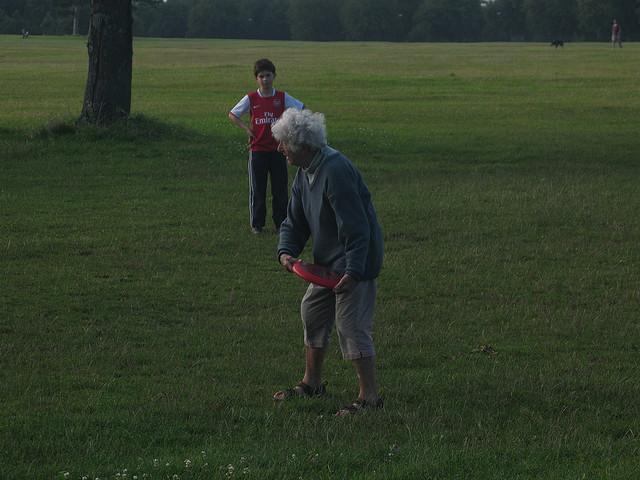Is it a hot day?
Be succinct. No. What color is the woman's sweater?
Keep it brief. Gray. What color is the man's jacket?
Give a very brief answer. Gray. Is this a cloudy day?
Answer briefly. Yes. What game are these people playing?
Concise answer only. Frisbee. Are both men wearing shorts?
Give a very brief answer. No. What color is the coat?
Answer briefly. Gray. Are they indoors or outside?
Give a very brief answer. Outside. What color is the frisbee?
Keep it brief. Red. What is the exact height of the grass?
Short answer required. 2 inches. Is the boy wearing a soccer jersey?
Give a very brief answer. Yes. How many people in this photo?
Be succinct. 2. What is the man wearing?
Concise answer only. Sweater. Is it sunny?
Short answer required. No. Does the grass need watering?
Be succinct. No. What animal is that?
Short answer required. Human. What are the white arms in the background producing?
Concise answer only. Nothing. Is there a fence around the property?
Short answer required. No. Is the guy throwing something?
Keep it brief. Yes. Is the woman talking on the cell phone?
Write a very short answer. No. Should someone help her with the launching?
Concise answer only. No. Could the boys be brothers?
Short answer required. No. Is the boy wearing visor?
Quick response, please. No. What color is his jacket?
Be succinct. Gray. What do their outfits have in common?
Give a very brief answer. Cotton. What sport are they playing?
Write a very short answer. Frisbee. What color are her pants?
Be succinct. Gray. What is the man holding?
Quick response, please. Frisbee. Is it a male or female throwing the frisbee?
Short answer required. Female. Is the child male or female?
Give a very brief answer. Male. Is the photo purposefully comedic?
Concise answer only. No. Is this lady dressed in costume?
Write a very short answer. No. Is is warm out?
Answer briefly. Yes. Is the woman about to throw the ball?
Keep it brief. No. What is on the man's shirt?
Answer briefly. Words. What is in the man's hand?
Write a very short answer. Frisbee. What are they flying?
Short answer required. Frisbee. Is there a woman wearing a blue shirt in the background?
Write a very short answer. No. Is it dark outside?
Short answer required. No. How many people are in the photo?
Be succinct. 2. What is flying behind the woman?
Answer briefly. Nothing. Are these people both wearing shoes?
Write a very short answer. Yes. How many people have red shirts?
Quick response, please. 1. Is everyone holding an umbrella?
Answer briefly. No. What are the girls trying to do?
Quick response, please. Play frisbee. Does the woman appear to be elderly?
Answer briefly. Yes. What is the lady trying to fly?
Write a very short answer. Frisbee. Are any buildings visible?
Write a very short answer. No. What is the woman throwing?
Short answer required. Frisbee. Are they playing baseball?
Be succinct. No. What are the people doing?
Concise answer only. Frisbee. Is the person who threw the frisbee a man?
Concise answer only. No. What kind of shoes is she wearing?
Keep it brief. Sandals. 